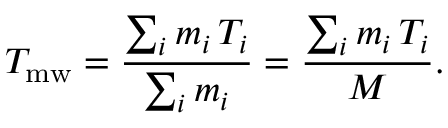<formula> <loc_0><loc_0><loc_500><loc_500>T _ { m w } = \frac { \sum _ { i } m _ { i } \, T _ { i } } { \sum _ { i } m _ { i } } = \frac { \sum _ { i } m _ { i } \, T _ { i } } { M } .</formula> 